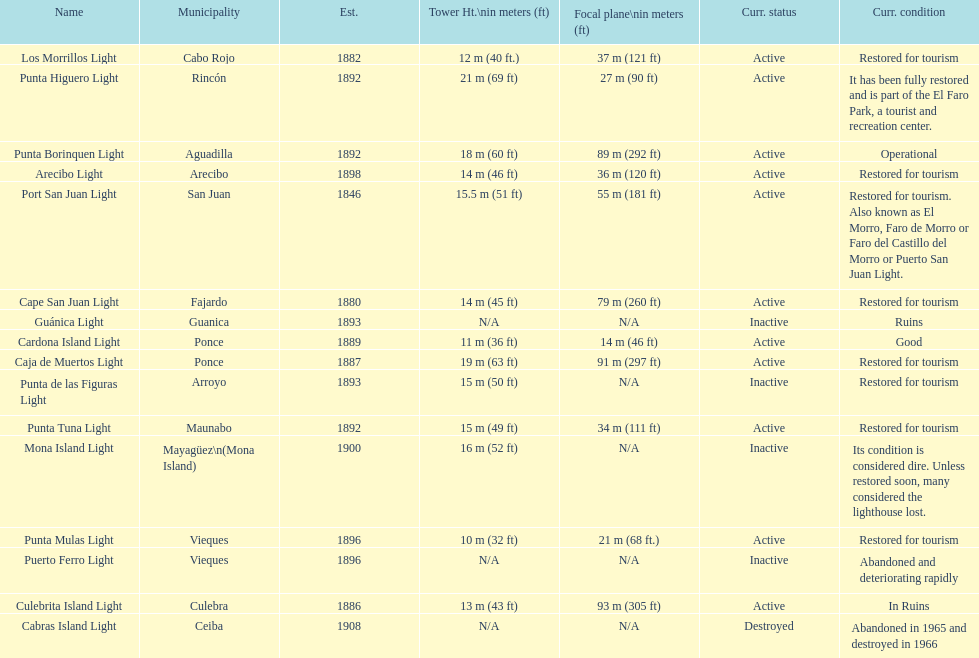Were any towers established before the year 1800? No. 